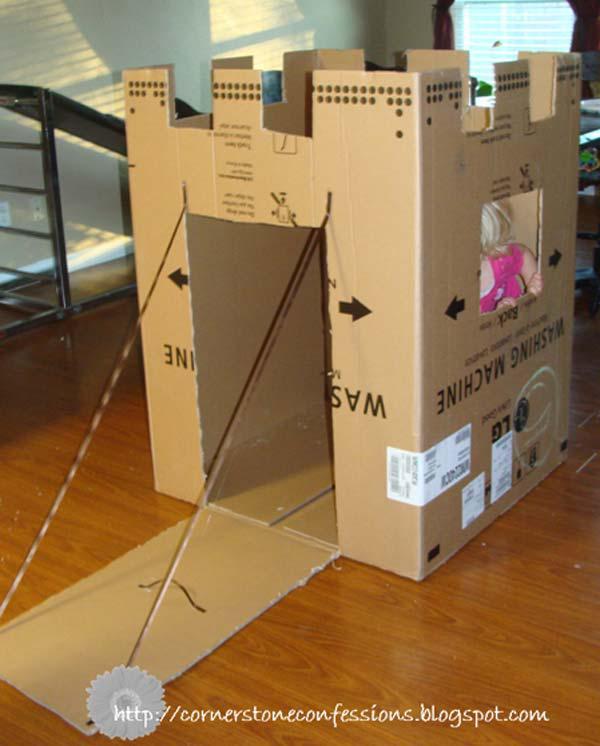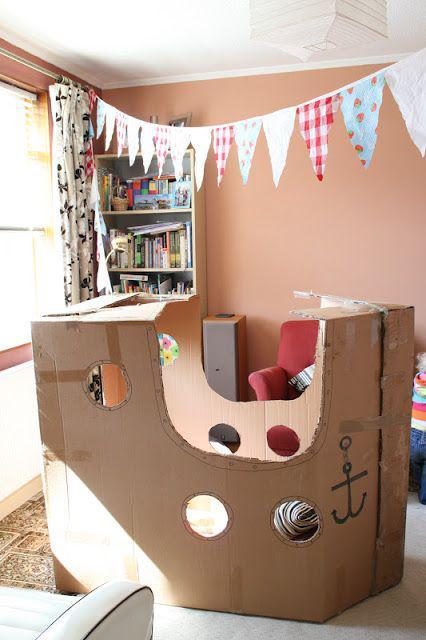The first image is the image on the left, the second image is the image on the right. Analyze the images presented: Is the assertion "One of the images shows a cardboard boat and another image shows a cardboard building." valid? Answer yes or no. Yes. The first image is the image on the left, the second image is the image on the right. Examine the images to the left and right. Is the description "The right image features at least one child inside a long boat made out of joined cardboard boxes." accurate? Answer yes or no. No. 